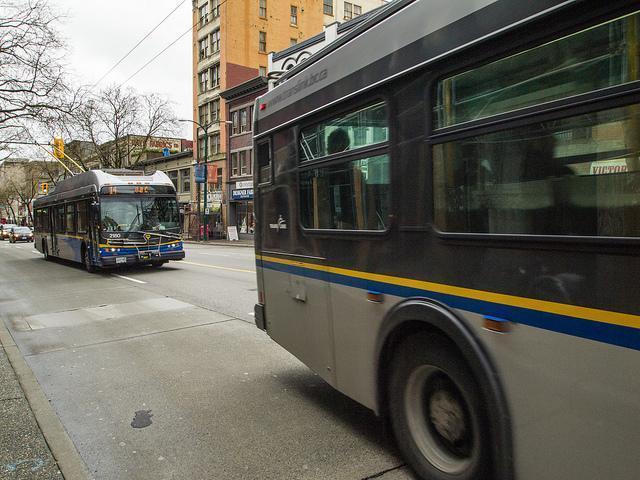How many buses are there?
Give a very brief answer. 2. How many buses are visible?
Give a very brief answer. 2. How many birds are visible?
Give a very brief answer. 0. 